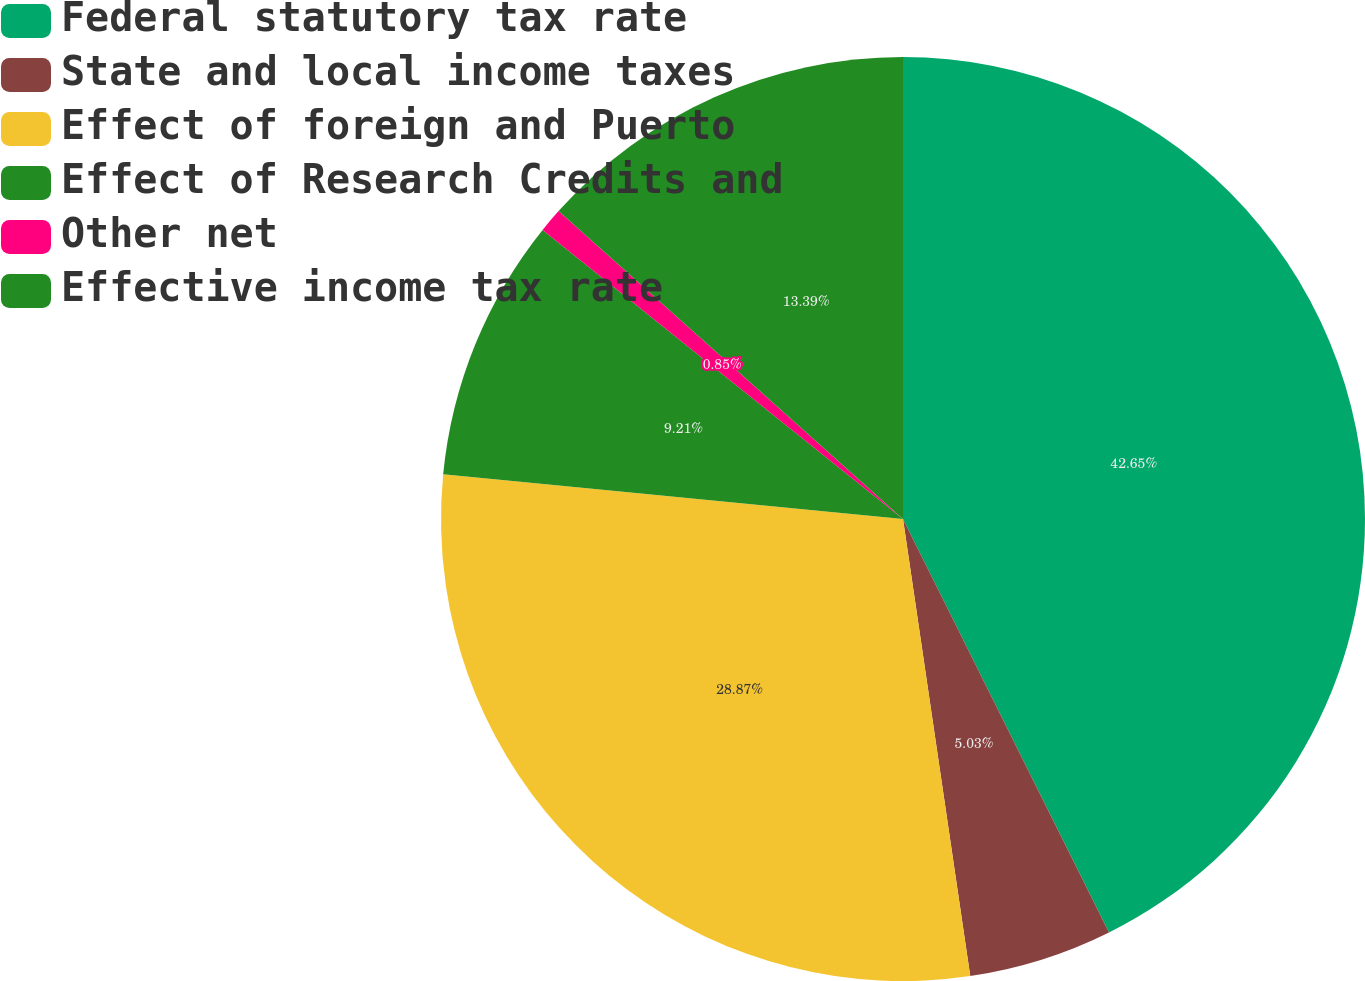<chart> <loc_0><loc_0><loc_500><loc_500><pie_chart><fcel>Federal statutory tax rate<fcel>State and local income taxes<fcel>Effect of foreign and Puerto<fcel>Effect of Research Credits and<fcel>Other net<fcel>Effective income tax rate<nl><fcel>42.64%<fcel>5.03%<fcel>28.87%<fcel>9.21%<fcel>0.85%<fcel>13.39%<nl></chart> 